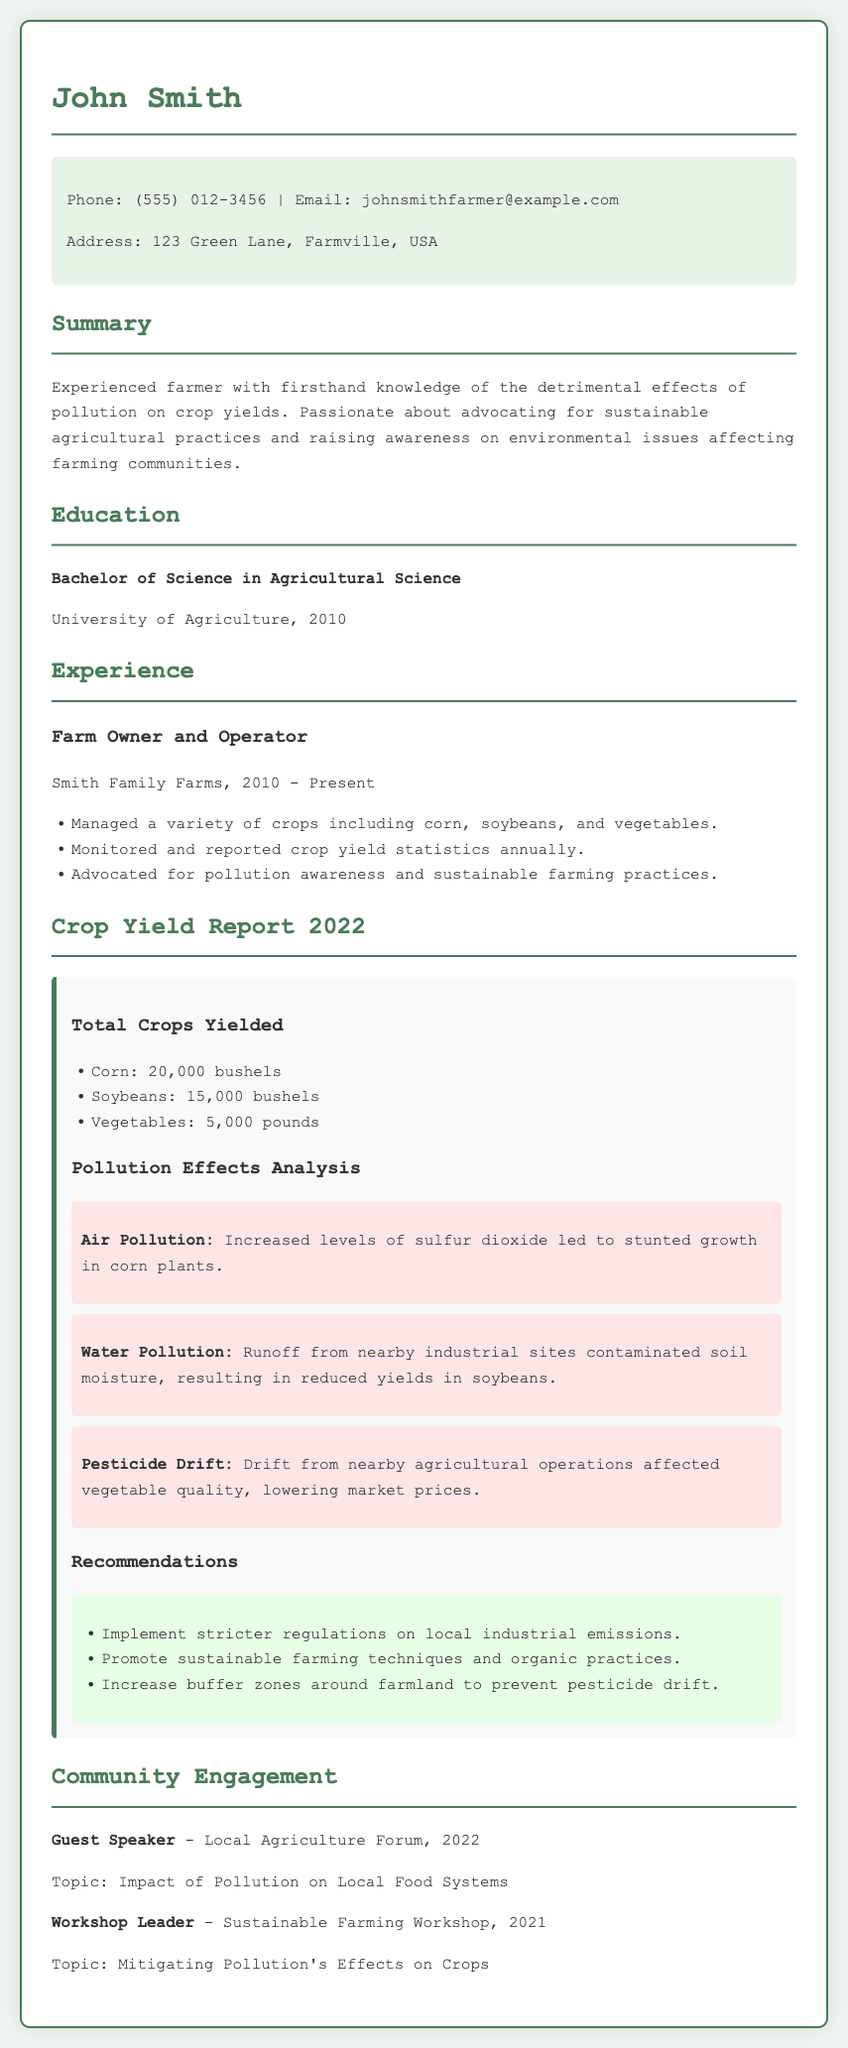what is the name of the farmer? The farmer's name is listed at the top of the document as John Smith.
Answer: John Smith what degree does John Smith hold? The document states that he has a Bachelor of Science in Agricultural Science.
Answer: Bachelor of Science in Agricultural Science how many bushels of corn were yielded in 2022? The yield for corn is specifically stated as 20,000 bushels in the crop yield report section.
Answer: 20,000 bushels what pollution effect is noted regarding air pollution? The document mentions that increased levels of sulfur dioxide led to stunted growth in corn plants.
Answer: Stunted growth in corn plants what is one recommendation made in the report? The report lists several recommendations, one of which is to implement stricter regulations on local industrial emissions.
Answer: Implement stricter regulations on local industrial emissions what year did John Smith start operating his farm? The experience section indicates that he began operating his farm in 2010.
Answer: 2010 which crops did John Smith manage on his farm? The experience section mentions corn, soybeans, and vegetables as the crops he managed.
Answer: Corn, soybeans, and vegetables what was the topic of the guest speaking engagement in 2022? The document notes that the topic was the impact of pollution on local food systems.
Answer: Impact of Pollution on Local Food Systems how long has John Smith been a farmer by 2022? Since he started in 2010 and the current year is 2022, he has been a farmer for 12 years.
Answer: 12 years 